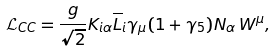<formula> <loc_0><loc_0><loc_500><loc_500>\mathcal { L } _ { C C } = \frac { g } { \sqrt { 2 } } K _ { i \alpha } \overline { L } _ { i } \gamma _ { \mu } ( 1 + \gamma _ { 5 } ) N _ { \alpha } \, W ^ { \mu } ,</formula> 